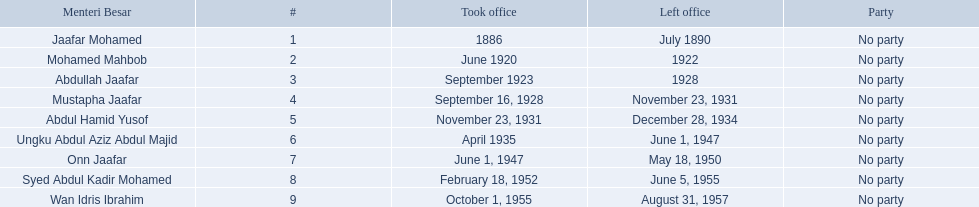When did jaafar mohamed take office? 1886. When did mohamed mahbob take office? June 1920. Who was in office no more than 4 years? Mohamed Mahbob. 